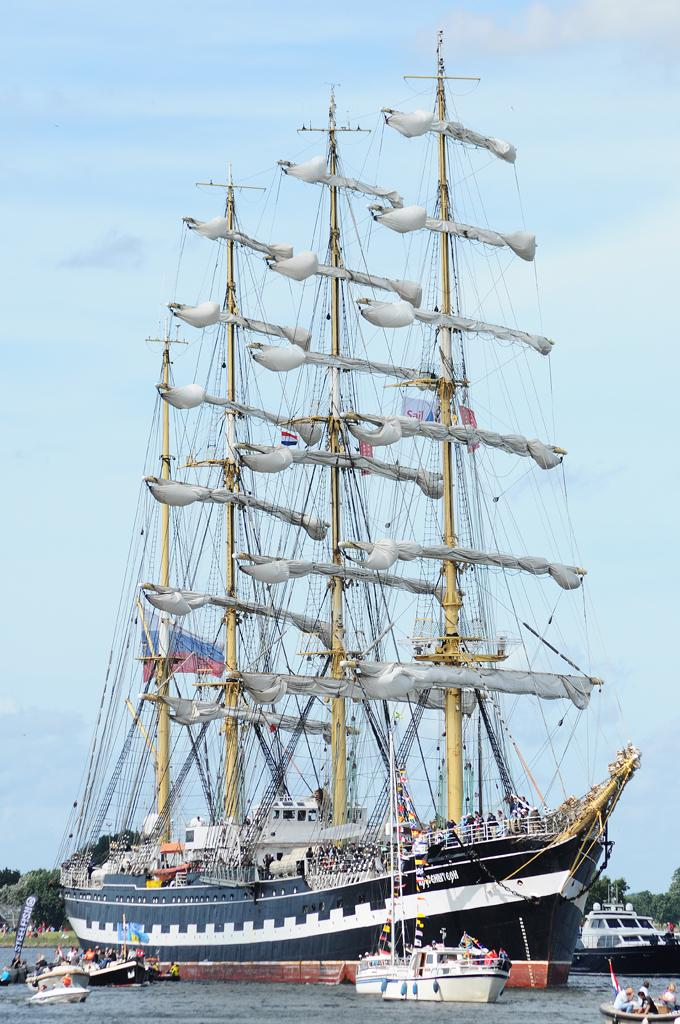Provide a one-sentence caption for the provided image. People are holding a Steelfish sign from a small boat that is next to a large ship. 